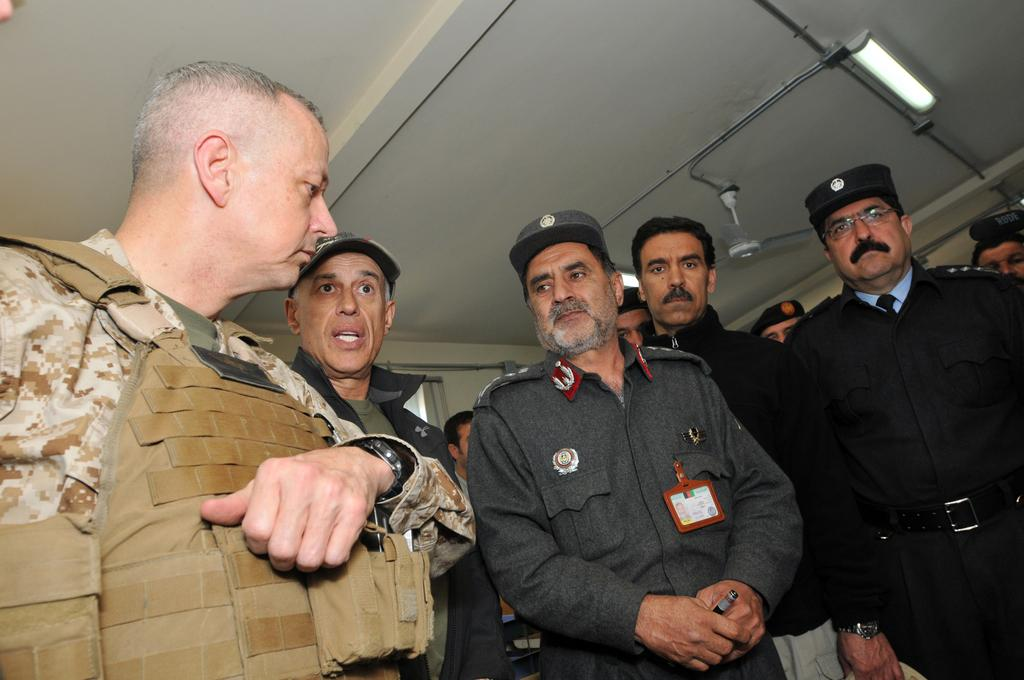How many people are in the image? There are many people standing in the image. Can you describe the person on the left side of the image? The person on the left side of the image is wearing a watch. What can be seen in the background of the image? There is a fan visible in the background of the image. What type of ice is being used to cool the doll in the image? There is no doll or ice present in the image. 